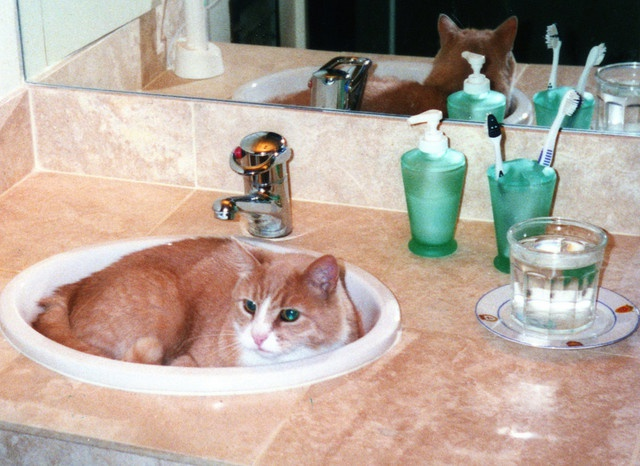Describe the objects in this image and their specific colors. I can see cat in white, brown, lightpink, lightgray, and darkgray tones, sink in white, tan, darkgray, and brown tones, cup in ivory, lightgray, darkgray, gray, and lightblue tones, bottle in ivory, turquoise, white, and teal tones, and cup in white, darkgray, lightblue, and gray tones in this image. 